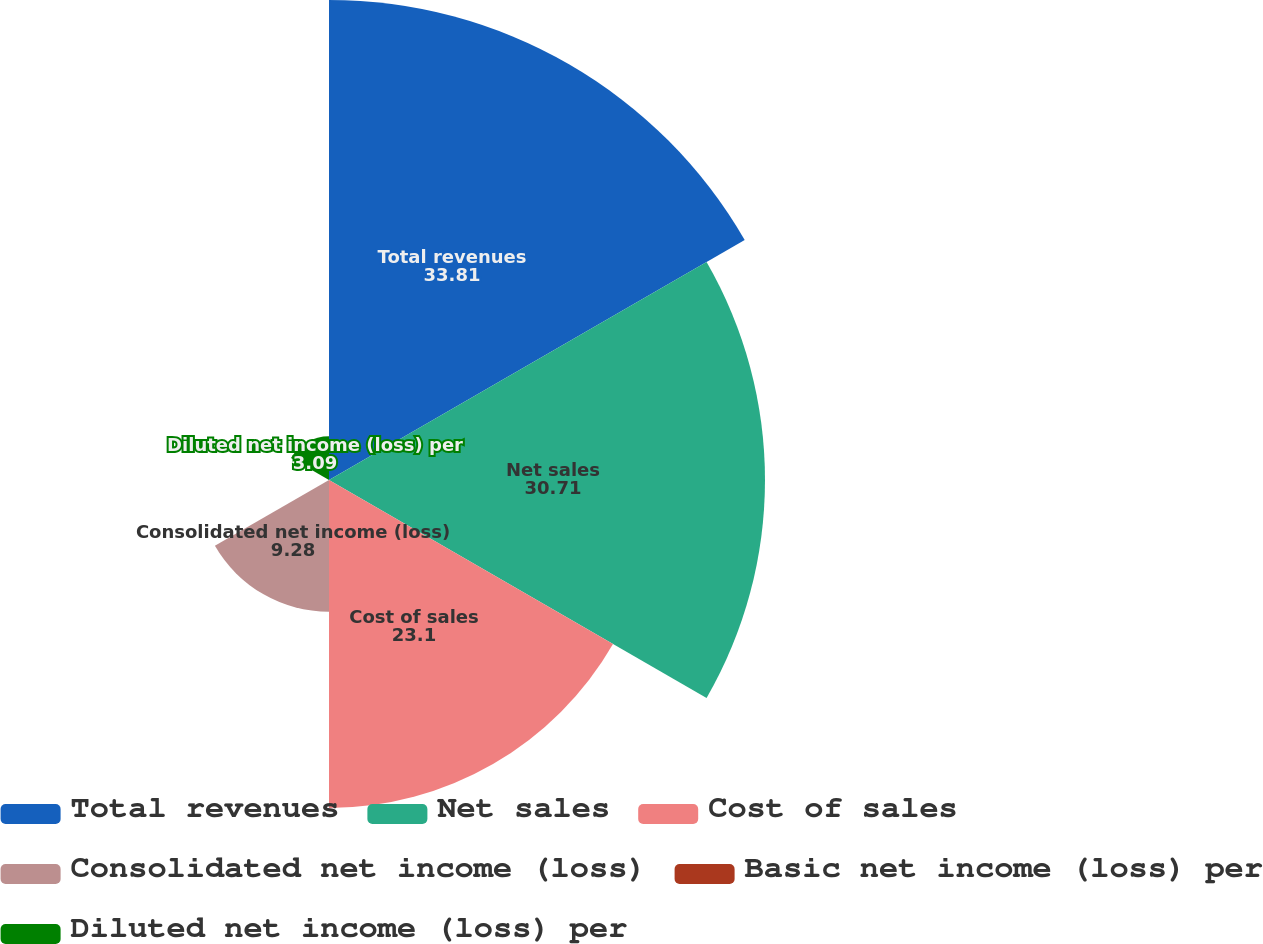<chart> <loc_0><loc_0><loc_500><loc_500><pie_chart><fcel>Total revenues<fcel>Net sales<fcel>Cost of sales<fcel>Consolidated net income (loss)<fcel>Basic net income (loss) per<fcel>Diluted net income (loss) per<nl><fcel>33.81%<fcel>30.71%<fcel>23.1%<fcel>9.28%<fcel>0.0%<fcel>3.09%<nl></chart> 